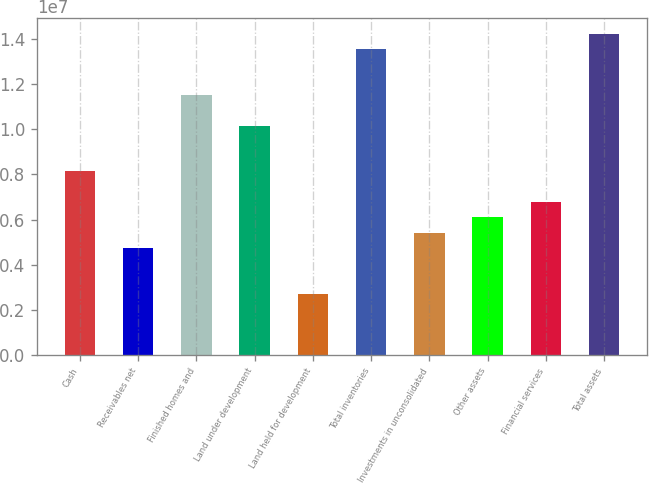Convert chart to OTSL. <chart><loc_0><loc_0><loc_500><loc_500><bar_chart><fcel>Cash<fcel>Receivables net<fcel>Finished homes and<fcel>Land under development<fcel>Land held for development<fcel>Total inventories<fcel>Investments in unconsolidated<fcel>Other assets<fcel>Financial services<fcel>Total assets<nl><fcel>8.12987e+06<fcel>4.74378e+06<fcel>1.1516e+07<fcel>1.01615e+07<fcel>2.71212e+06<fcel>1.35476e+07<fcel>5.421e+06<fcel>6.09821e+06<fcel>6.77543e+06<fcel>1.42248e+07<nl></chart> 